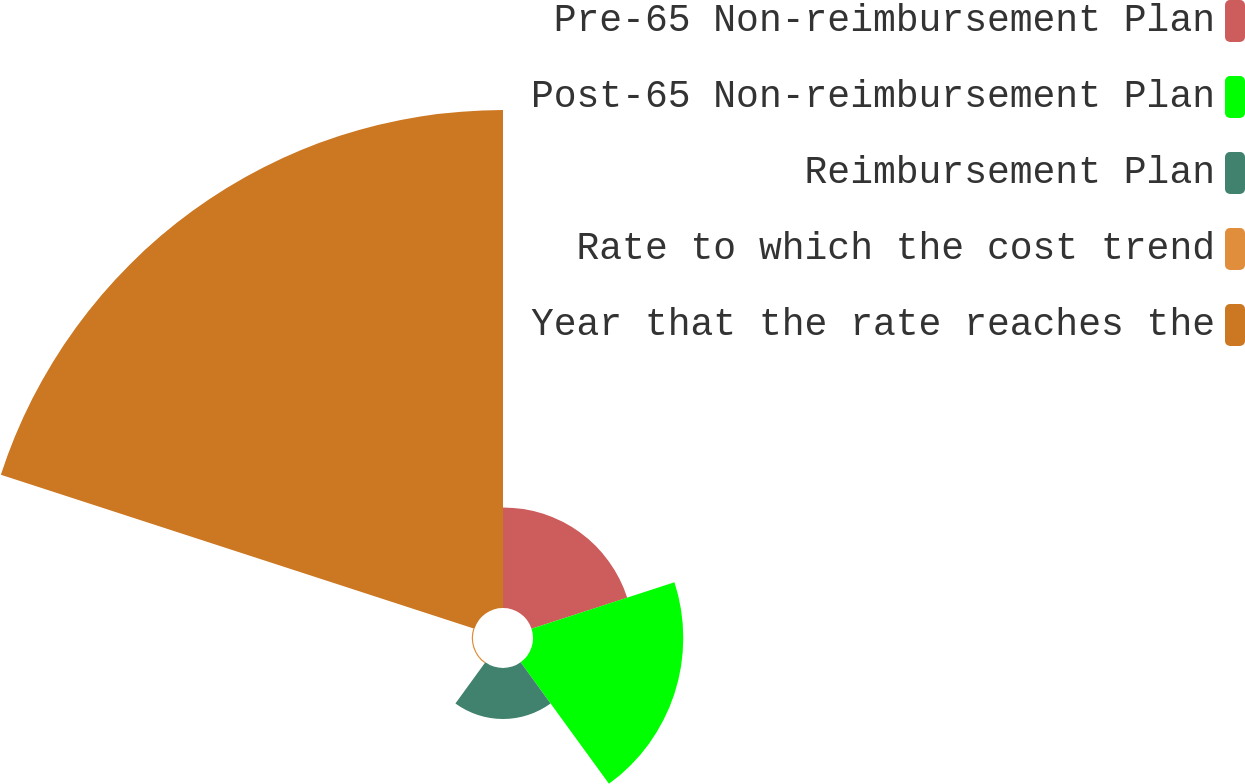Convert chart. <chart><loc_0><loc_0><loc_500><loc_500><pie_chart><fcel>Pre-65 Non-reimbursement Plan<fcel>Post-65 Non-reimbursement Plan<fcel>Reimbursement Plan<fcel>Rate to which the cost trend<fcel>Year that the rate reaches the<nl><fcel>12.56%<fcel>18.76%<fcel>6.36%<fcel>0.15%<fcel>62.17%<nl></chart> 